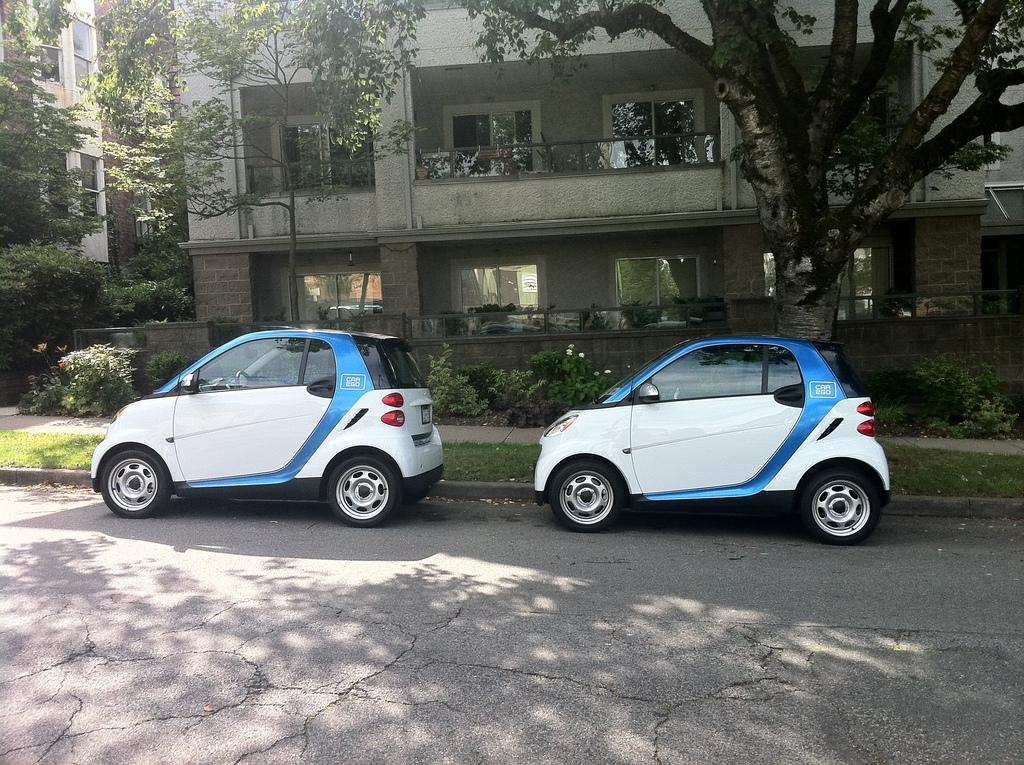What is located in the center of the image? There are cars, grass, and plants in the center of the image. What can be seen in the background of the image? There are buildings, trees, windows, and a balcony in the background of the image. What is at the top of the image? There is a road at the top of the image. How many hands are visible in the image? There are no hands visible in the image. Is there an island in the center of the image? There is no island present in the image; it features cars, grass, and plants in the center. 